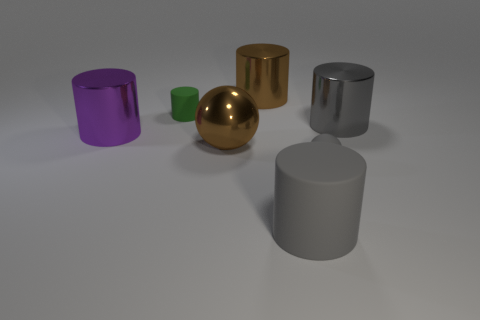Add 2 gray shiny objects. How many objects exist? 9 Subtract all big gray matte cylinders. How many cylinders are left? 4 Subtract all brown spheres. How many spheres are left? 1 Subtract 1 spheres. How many spheres are left? 1 Subtract all green balls. Subtract all blue cylinders. How many balls are left? 2 Subtract all red cubes. How many brown spheres are left? 1 Subtract all large metallic cylinders. Subtract all gray cylinders. How many objects are left? 2 Add 2 tiny gray rubber objects. How many tiny gray rubber objects are left? 3 Add 1 green metal cylinders. How many green metal cylinders exist? 1 Subtract 0 gray blocks. How many objects are left? 7 